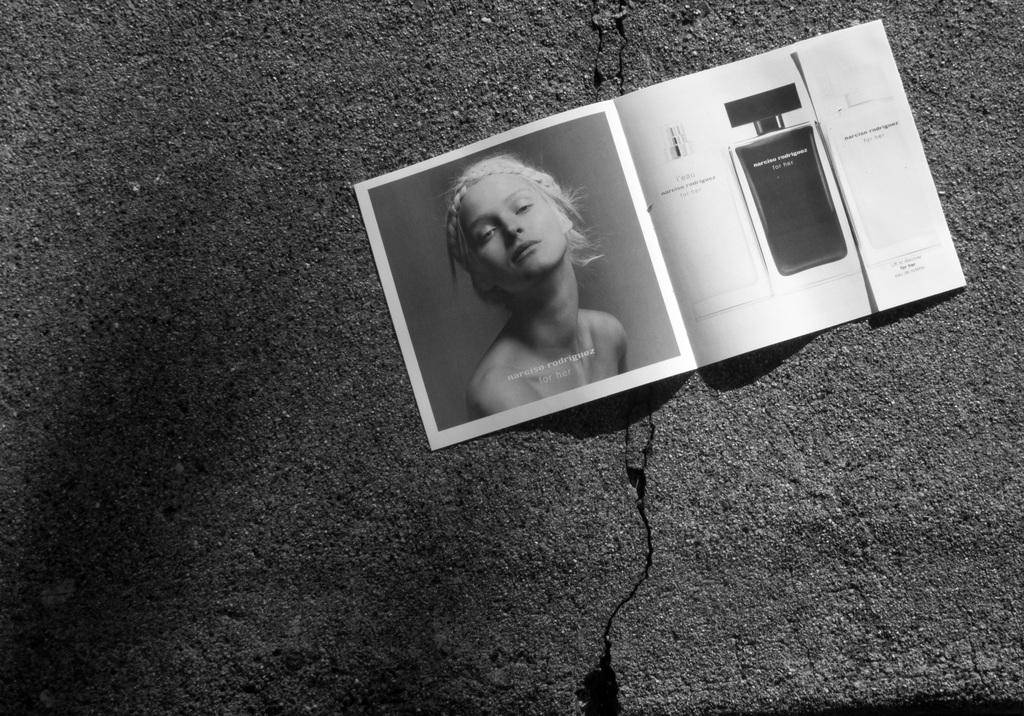What is the color scheme of the image? The image is black and white. What is the main object in the image? There is a paper in the image. What is depicted on the paper? The paper has a photo of a woman on it. Are there any other items visible in the image? Yes, there are additional items visible in the image. What type of noise can be heard coming from the laborer in the image? There is no laborer present in the image, so it's not possible to determine what noise might be heard. 